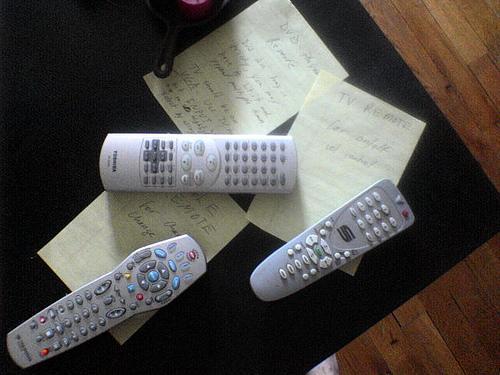How many remotes?
Give a very brief answer. 3. How many remotes are there?
Give a very brief answer. 3. 